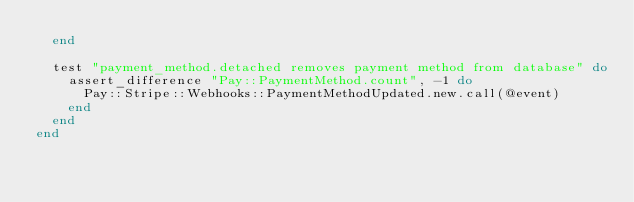<code> <loc_0><loc_0><loc_500><loc_500><_Ruby_>  end

  test "payment_method.detached removes payment method from database" do
    assert_difference "Pay::PaymentMethod.count", -1 do
      Pay::Stripe::Webhooks::PaymentMethodUpdated.new.call(@event)
    end
  end
end
</code> 